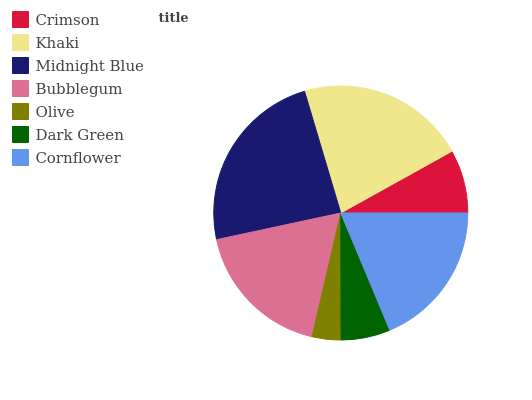Is Olive the minimum?
Answer yes or no. Yes. Is Midnight Blue the maximum?
Answer yes or no. Yes. Is Khaki the minimum?
Answer yes or no. No. Is Khaki the maximum?
Answer yes or no. No. Is Khaki greater than Crimson?
Answer yes or no. Yes. Is Crimson less than Khaki?
Answer yes or no. Yes. Is Crimson greater than Khaki?
Answer yes or no. No. Is Khaki less than Crimson?
Answer yes or no. No. Is Bubblegum the high median?
Answer yes or no. Yes. Is Bubblegum the low median?
Answer yes or no. Yes. Is Crimson the high median?
Answer yes or no. No. Is Dark Green the low median?
Answer yes or no. No. 